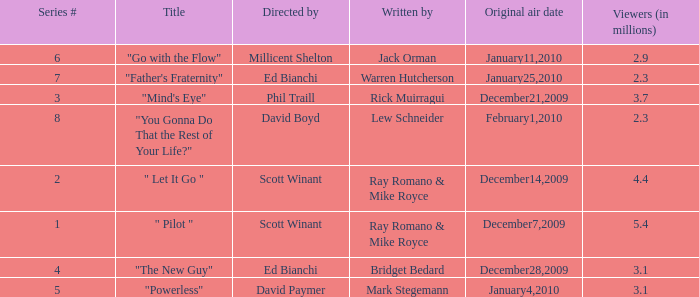How many episodes are written by Lew Schneider? 1.0. 